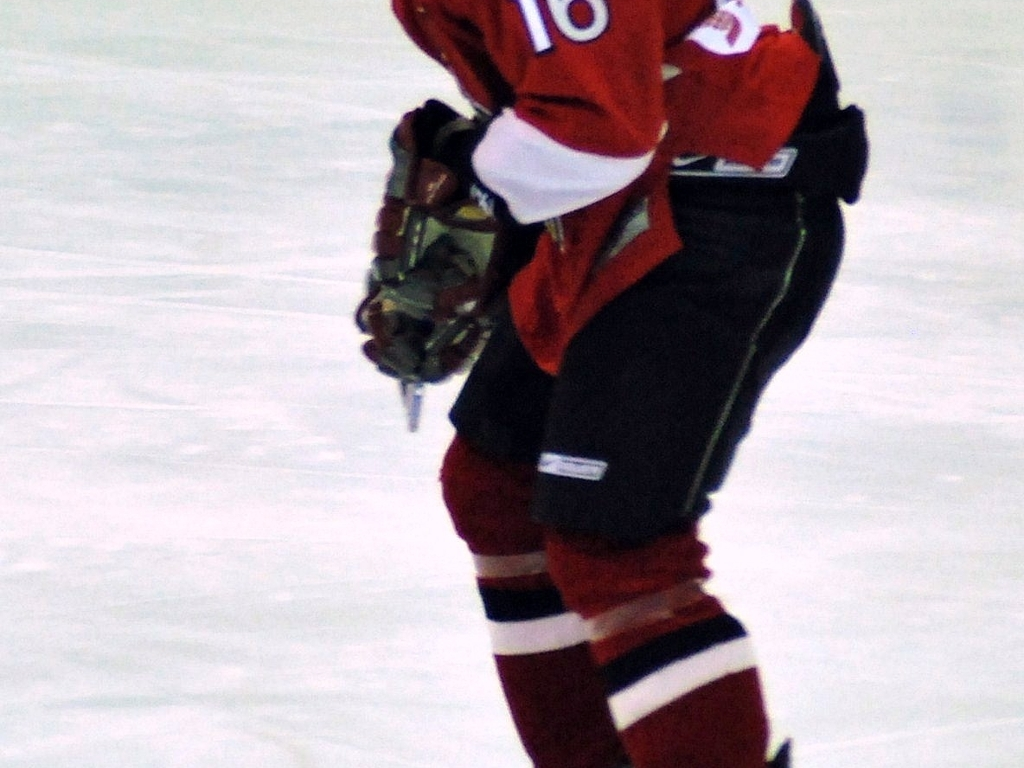Can you describe the equipment this player is holding? The player is holding a hockey stick, which is an essential piece of equipment for handling the puck, passing to teammates, and shooting goals in the game of ice hockey. 